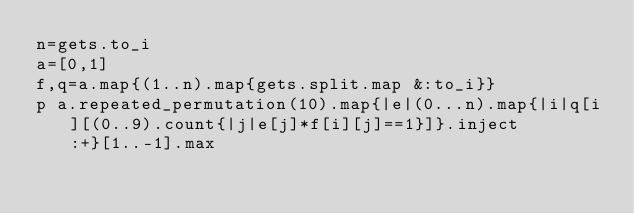Convert code to text. <code><loc_0><loc_0><loc_500><loc_500><_Ruby_>n=gets.to_i
a=[0,1]
f,q=a.map{(1..n).map{gets.split.map &:to_i}}
p a.repeated_permutation(10).map{|e|(0...n).map{|i|q[i][(0..9).count{|j|e[j]*f[i][j]==1}]}.inject :+}[1..-1].max</code> 